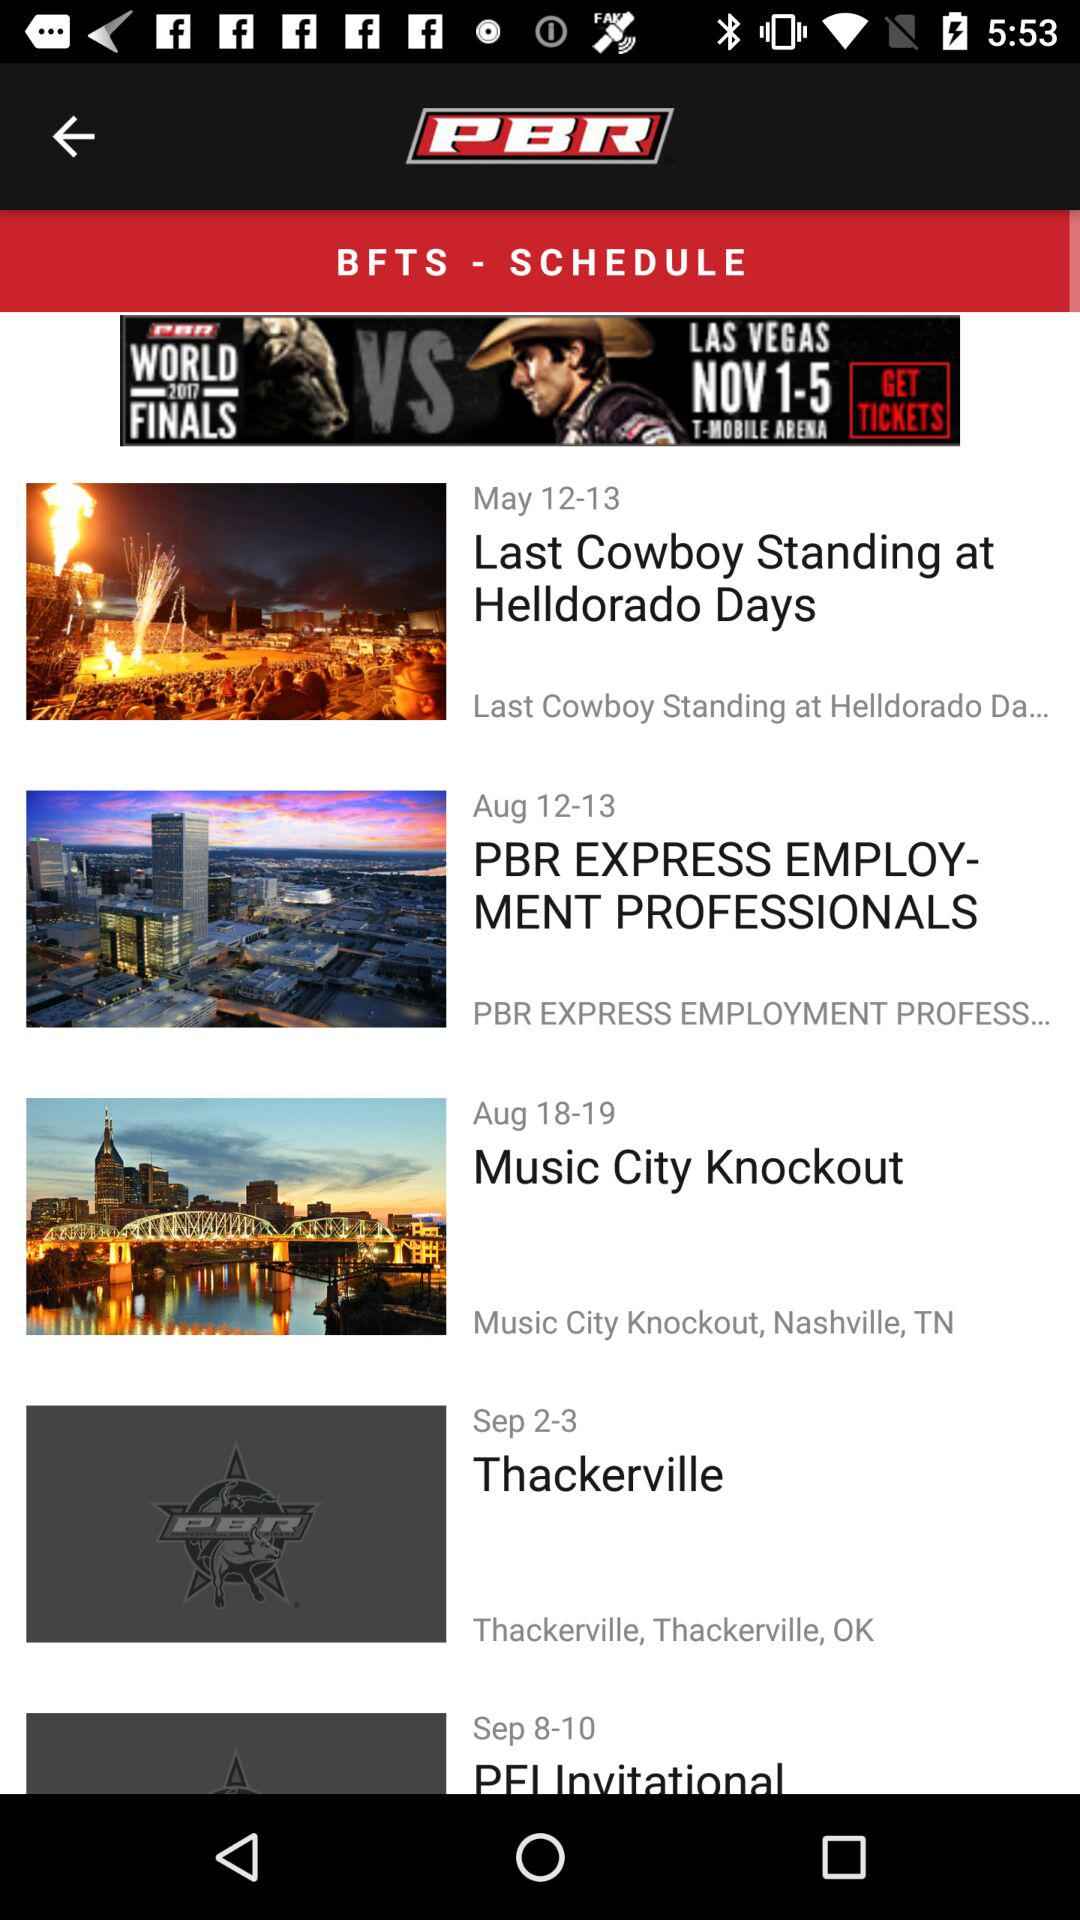How many events are in the schedule?
Answer the question using a single word or phrase. 5 